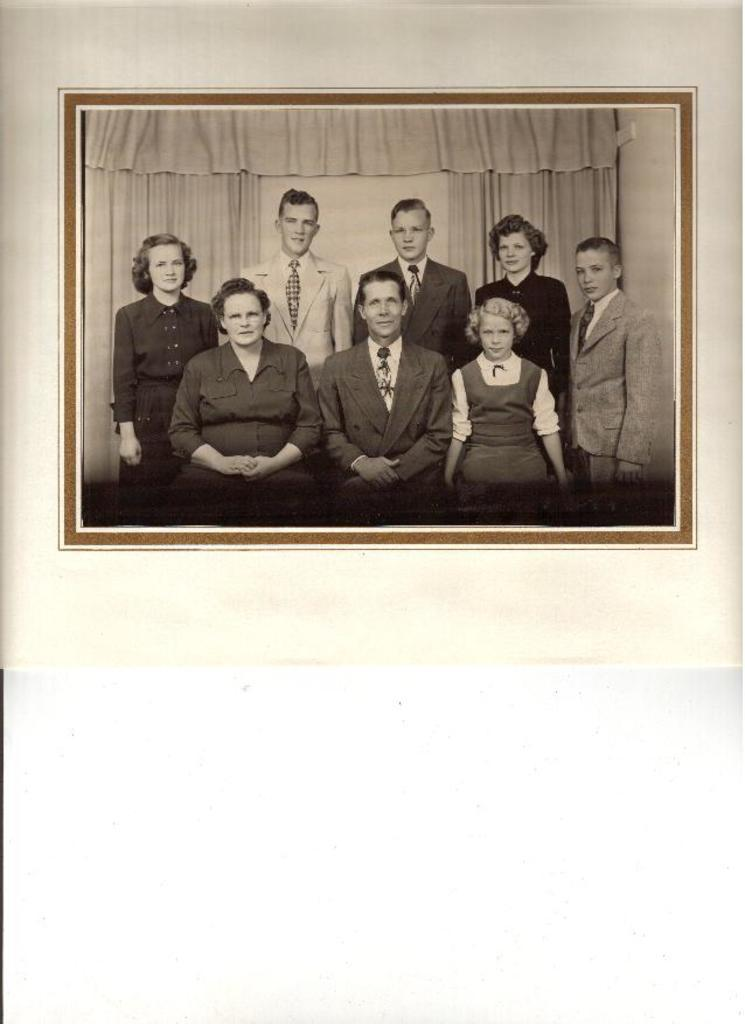What are the people in the image doing? There are persons sitting and standing in the picture. Can you describe the background of the image? There is a curtain in the background of the image. What type of note is being passed between the persons in the image? There is no note being passed between the persons in the image. What kind of beast can be seen lurking in the background? There is no beast present in the image; only the curtain is visible in the background. 